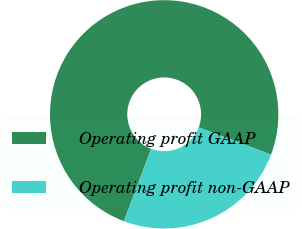Convert chart to OTSL. <chart><loc_0><loc_0><loc_500><loc_500><pie_chart><fcel>Operating profit GAAP<fcel>Operating profit non-GAAP<nl><fcel>75.0%<fcel>25.0%<nl></chart> 